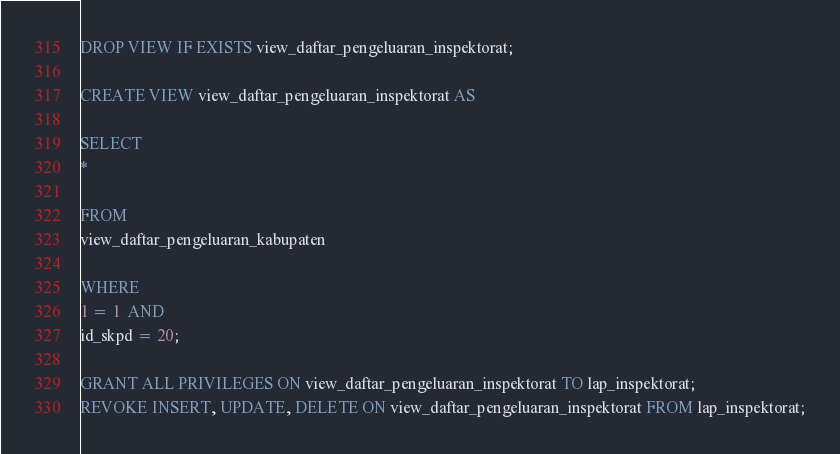<code> <loc_0><loc_0><loc_500><loc_500><_SQL_>DROP VIEW IF EXISTS view_daftar_pengeluaran_inspektorat;

CREATE VIEW view_daftar_pengeluaran_inspektorat AS

SELECT
*

FROM
view_daftar_pengeluaran_kabupaten

WHERE
1 = 1  AND
id_skpd = 20;

GRANT ALL PRIVILEGES ON view_daftar_pengeluaran_inspektorat TO lap_inspektorat;
REVOKE INSERT, UPDATE, DELETE ON view_daftar_pengeluaran_inspektorat FROM lap_inspektorat;
</code> 